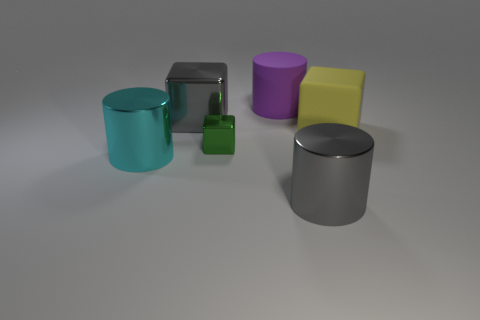Add 1 big gray metal things. How many objects exist? 7 Subtract all purple rubber cylinders. How many cylinders are left? 2 Subtract 1 cylinders. How many cylinders are left? 2 Subtract all blue blocks. Subtract all cyan balls. How many blocks are left? 3 Subtract all small green metal blocks. Subtract all matte spheres. How many objects are left? 5 Add 6 gray blocks. How many gray blocks are left? 7 Add 4 large purple shiny cylinders. How many large purple shiny cylinders exist? 4 Subtract 0 purple spheres. How many objects are left? 6 